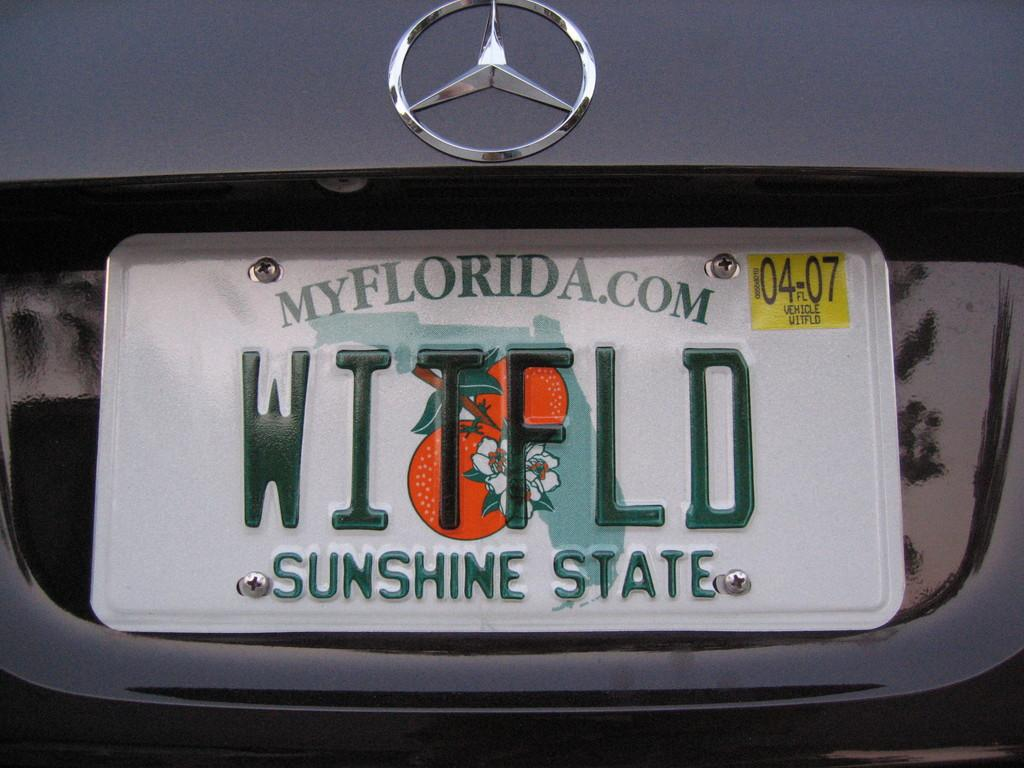<image>
Share a concise interpretation of the image provided. Florida license plate number WITFLD is on a Mercedes. 